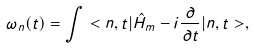Convert formula to latex. <formula><loc_0><loc_0><loc_500><loc_500>\omega _ { n } ( t ) = \int < n , t | \hat { H } _ { m } - i \frac { \partial } { \partial t } | n , t > ,</formula> 